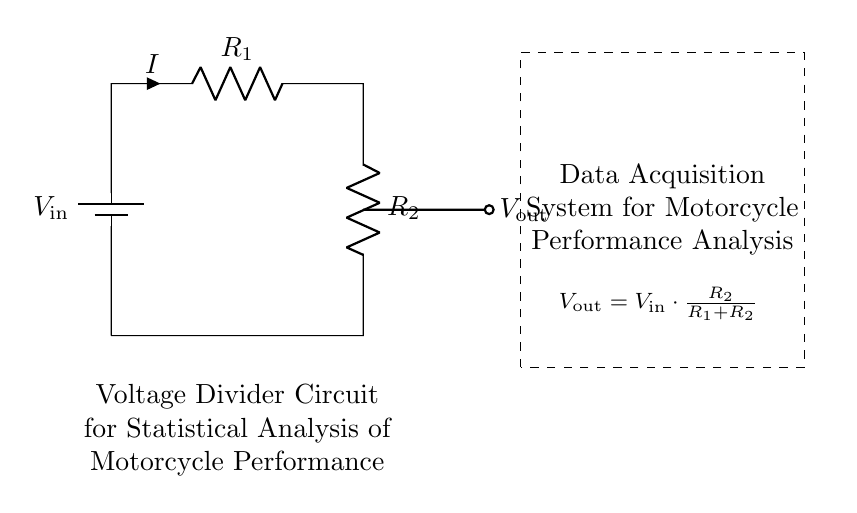What does R1 represent in this circuit? R1 is a resistor in the voltage divider circuit, and it contributes to the total resistance alongside R2.
Answer: Resistor What is the relationship between Vout and Vin? Vout is derived from Vin based on the voltage divider formula, which is a fraction of Vin indicated by the ratio of R2 to the total resistance (R1 + R2).
Answer: Vout = Vin * (R2 / (R1 + R2)) What is the function of the battery in this circuit? The battery provides the input voltage, Vin, which powers the voltage divider and allows it to output a lower voltage, Vout, across R2.
Answer: Input voltage If R1 is twice the value of R2, what would be the output voltage Vout in terms of Vin? If R1 = 2R2, then substituting into the voltage divider formula shows that Vout = Vin * (R2 / (2R2 + R2)) = Vin / 3, indicating that the output is one-third of the input voltage.
Answer: Vin / 3 What measures are necessary to ensure accurate data acquisition from this circuit? Proper calibration of the circuit components and ensuring that the connections are secure are necessary for accurate data readings to eliminate noise or erroneous signals.
Answer: Calibration and secure connections What would happen if R2 is very small compared to R1? If R2 is very small, then Vout will be very close to 0 volts since most of the input voltage Vin drops across R1 due to the high resistance when compared to R1.
Answer: Vout approaches 0 volts 